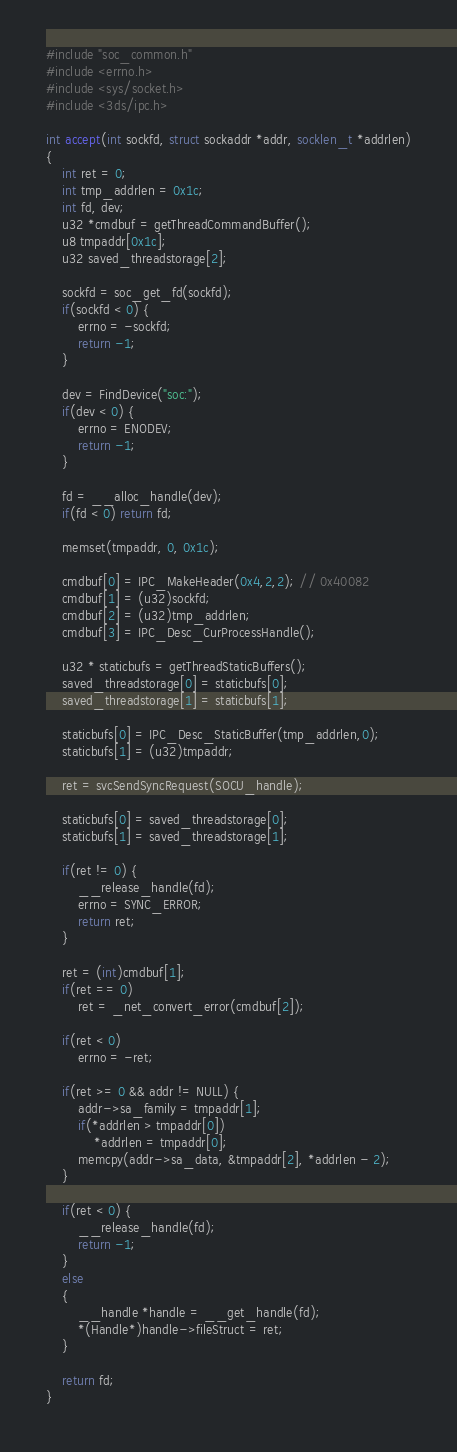<code> <loc_0><loc_0><loc_500><loc_500><_C_>#include "soc_common.h"
#include <errno.h>
#include <sys/socket.h>
#include <3ds/ipc.h>

int accept(int sockfd, struct sockaddr *addr, socklen_t *addrlen)
{
	int ret = 0;
	int tmp_addrlen = 0x1c;
	int fd, dev;
	u32 *cmdbuf = getThreadCommandBuffer();
	u8 tmpaddr[0x1c];
	u32 saved_threadstorage[2];

	sockfd = soc_get_fd(sockfd);
	if(sockfd < 0) {
		errno = -sockfd;
		return -1;
	}

	dev = FindDevice("soc:");
	if(dev < 0) {
		errno = ENODEV;
		return -1;
	}

	fd = __alloc_handle(dev);
	if(fd < 0) return fd;

	memset(tmpaddr, 0, 0x1c);

	cmdbuf[0] = IPC_MakeHeader(0x4,2,2); // 0x40082
	cmdbuf[1] = (u32)sockfd;
	cmdbuf[2] = (u32)tmp_addrlen;
	cmdbuf[3] = IPC_Desc_CurProcessHandle();

	u32 * staticbufs = getThreadStaticBuffers();
	saved_threadstorage[0] = staticbufs[0];
	saved_threadstorage[1] = staticbufs[1];

	staticbufs[0] = IPC_Desc_StaticBuffer(tmp_addrlen,0);
	staticbufs[1] = (u32)tmpaddr;

	ret = svcSendSyncRequest(SOCU_handle);

	staticbufs[0] = saved_threadstorage[0];
	staticbufs[1] = saved_threadstorage[1];

	if(ret != 0) {
		__release_handle(fd);
		errno = SYNC_ERROR;
		return ret;
	}

	ret = (int)cmdbuf[1];
	if(ret == 0)
		ret = _net_convert_error(cmdbuf[2]);

	if(ret < 0)
		errno = -ret;

	if(ret >= 0 && addr != NULL) {
		addr->sa_family = tmpaddr[1];
		if(*addrlen > tmpaddr[0])
			*addrlen = tmpaddr[0];
		memcpy(addr->sa_data, &tmpaddr[2], *addrlen - 2);
	}

	if(ret < 0) {
		__release_handle(fd);
		return -1;
	}
	else
	{
		__handle *handle = __get_handle(fd);
		*(Handle*)handle->fileStruct = ret;
	}

	return fd;
}
</code> 